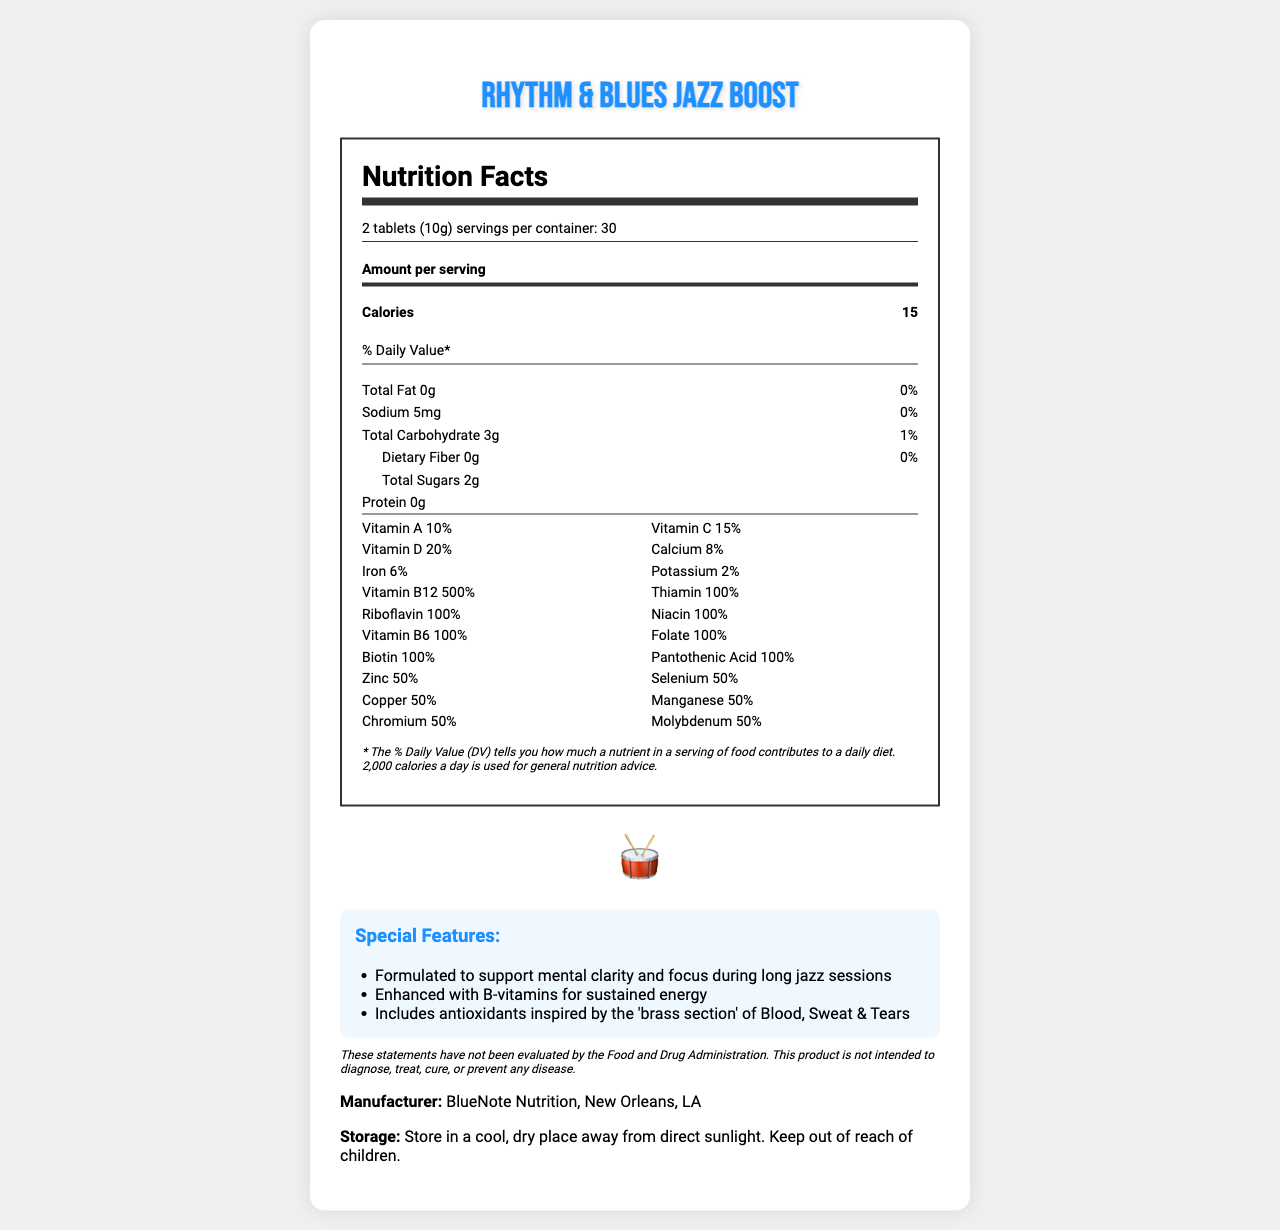what is the serving size for Rhythm & Blues Jazz Boost? The serving size is mentioned at the top of the Nutrition Facts label, under the serving information section.
Answer: 2 tablets (10g) how many servings are in one container of Rhythm & Blues Jazz Boost? This information is found in the serving information section, which states "servings per container: 30".
Answer: 30 how many calories are in one serving of Rhythm & Blues Jazz Boost? The calories per serving are listed right below the "Amount per serving" section under the nutrition label.
Answer: 15 how much vitamin B12 is in a serving? This information is part of the vitamins section, which lists Vitamin B12 as 500% of the daily value.
Answer: 500% what are the main ingredients in the proprietary blend? The proprietary blend ingredients are listed in the document under the proprietary blend section.
Answer: Ginkgo Biloba Extract, Green Tea Extract, Ginseng Root Extract, Bacopa Monnieri Extract, L-Theanine, Rhodiola Rosea Extract which vitamin has the highest percentage of daily value per serving? A. Vitamin C B. Vitamin D C. Vitamin B12 D. Calcium According to the vitamins section, Vitamin B12 has a daily value of 500%, the highest among all listed vitamins.
Answer: C. Vitamin B12 what is the sodium content per serving? A. 0mg B. 5mg C. 10mg D. 20mg The sodium content per serving is listed as 5mg under the nutrient section of the nutrition label.
Answer: B. 5mg does the supplement contain any dietary fiber? The dietary fiber content is listed as 0g under the total carbohydrate section of the nutrition label.
Answer: No is this supplement intended to diagnose, treat, cure, or prevent any disease? According to the disclaimer at the end of the document, these statements have not been evaluated by the FDA, and the product is not intended to diagnose, treat, cure, or prevent any disease.
Answer: No summarize the special features of Rhythm & Blues Jazz Boost. The special features section of the document details these unique characteristics of the supplement.
Answer: The Rhythm & Blues Jazz Boost is formulated to support mental clarity and focus during long jazz sessions, enhanced with B-vitamins for sustained energy, and includes antioxidants inspired by the 'brass section' of Blood, Sweat & Tears. what is the shape of the container? The container shape is specified as drum-shaped at the beginning of the document.
Answer: Drum-shaped where is the manufacturer of the Rhythm & Blues Jazz Boost located? The manufacturer's information is listed toward the end of the document, specifying BlueNote Nutrition as being based in New Orleans, LA.
Answer: New Orleans, LA how much total fat is in a serving of this supplement? The total fat content is listed under the nutrition label as 0g.
Answer: 0g are there any known allergens in Rhythm & Blues Jazz Boost? The allergen information section states that the supplement contains no known allergens.
Answer: No what forms of vitamin are included in the supplement besides Vitamin B12? The vitamins section lists all the different forms of vitamins included in the supplement besides Vitamin B12.
Answer: Vitamin A, Vitamin C, Vitamin D, Thiamin, Riboflavin, Niacin, Vitamin B6, Folate, Biotin, Pantothenic Acid which ingredient is not listed in the proprietary blend? A. Ginkgo Biloba Extract B. Green Tea Extract C. Ginseng Root Extract D. Microcrystalline Cellulose Microcrystalline Cellulose is listed under other ingredients, not under the proprietary blend.
Answer: D. Microcrystalline Cellulose how should the supplement be stored? The storage instructions section provides this information clearly.
Answer: Store in a cool, dry place away from direct sunlight, Keep out of reach of children. what is the total weight of the proprietary blend in each serving? This information is provided in the proprietary blend section, stating the total weight of the blend per serving.
Answer: 500mg how much iron is in a serving? The information is available under the vitamins section, where iron is listed as 6% of the daily value.
Answer: 6% what is the purpose of the supplement? The document provides nutritional and ingredient details but does not specify the exact purpose or target benefits of the supplement except for general support for mental clarity and focus during jazz sessions.
Answer: Cannot be determined 